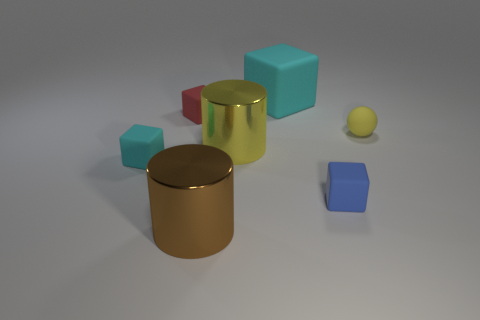What is the cylinder that is behind the rubber block that is on the right side of the big cube made of?
Your response must be concise. Metal. Do the shiny thing that is behind the blue rubber block and the tiny ball have the same color?
Give a very brief answer. Yes. How many other tiny matte things have the same shape as the blue thing?
Offer a very short reply. 2. What size is the yellow thing that is made of the same material as the large block?
Offer a very short reply. Small. Is there a blue thing behind the large metallic object in front of the small blue matte block behind the brown metallic thing?
Ensure brevity in your answer.  Yes. Is the size of the cyan cube that is left of the brown thing the same as the large matte thing?
Ensure brevity in your answer.  No. What number of objects are the same size as the brown cylinder?
Your response must be concise. 2. The other matte thing that is the same color as the large matte object is what size?
Offer a very short reply. Small. What shape is the big yellow metallic object?
Your answer should be very brief. Cylinder. Are there any small matte cubes of the same color as the large block?
Your answer should be compact. Yes. 